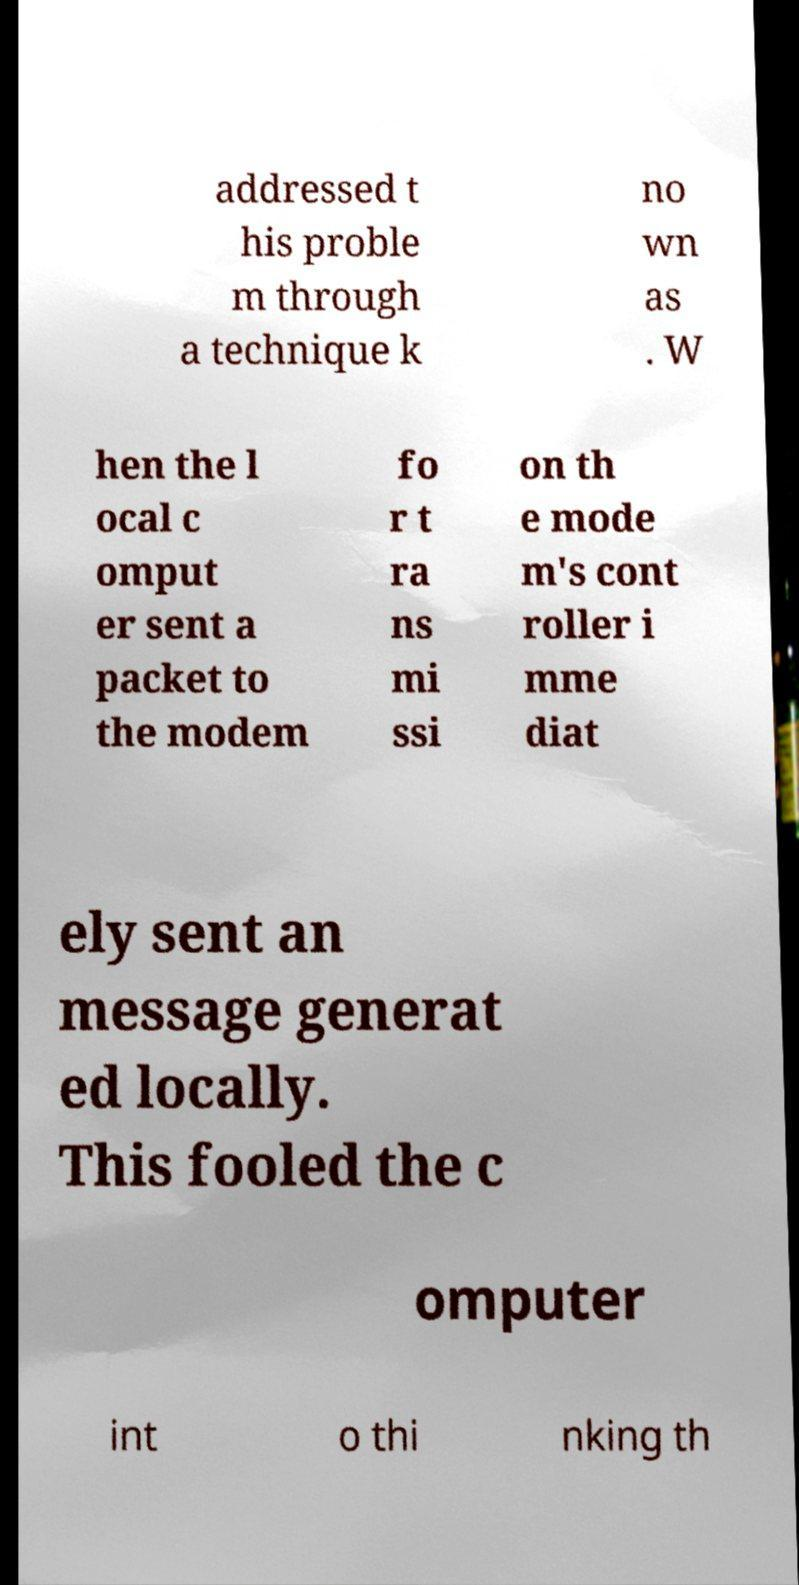Please read and relay the text visible in this image. What does it say? addressed t his proble m through a technique k no wn as . W hen the l ocal c omput er sent a packet to the modem fo r t ra ns mi ssi on th e mode m's cont roller i mme diat ely sent an message generat ed locally. This fooled the c omputer int o thi nking th 